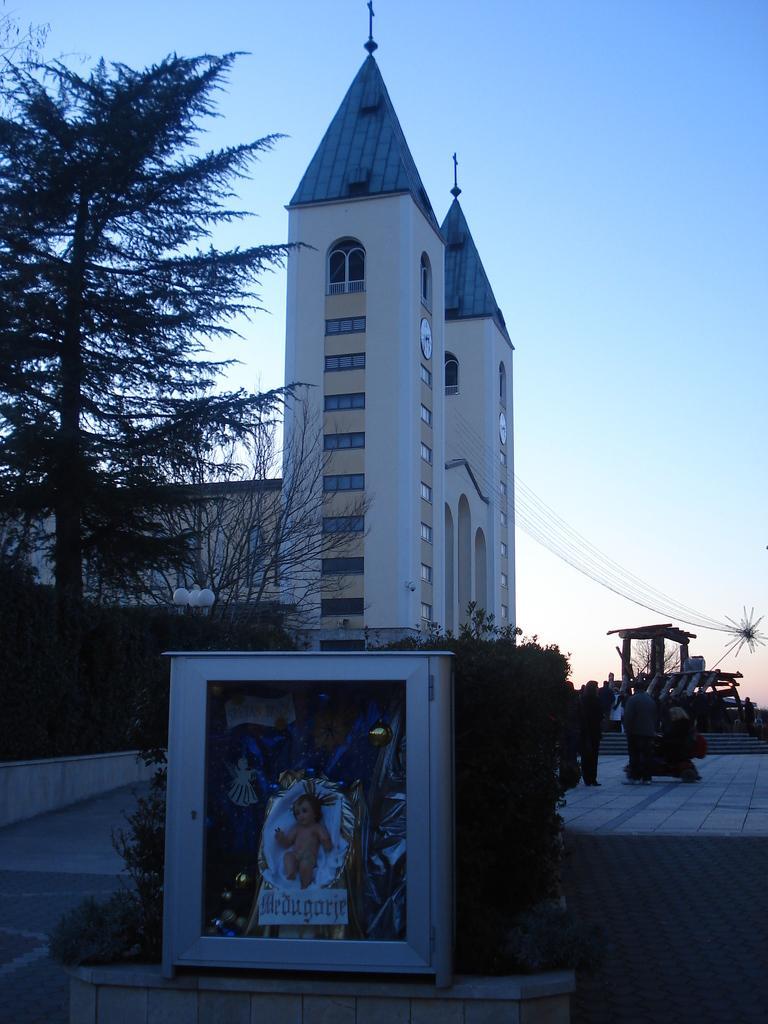Can you describe this image briefly? In the center of the image there is a box. On the box, we can see one poster, in which we can see one baby and we can see something written on it. In the background, we can see the sky, buildings, trees, poles, few people are standing, staircase etc. 